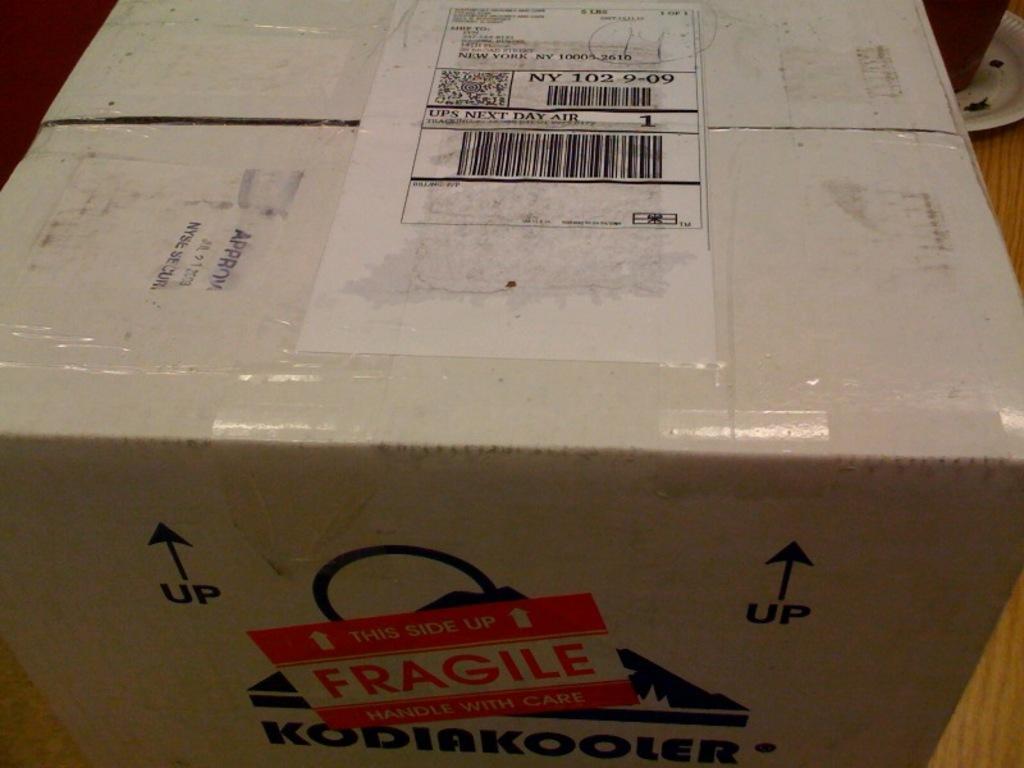In one or two sentences, can you explain what this image depicts? In this image I can see the cardboard box and the box is in white color and I can see the brown color background. 